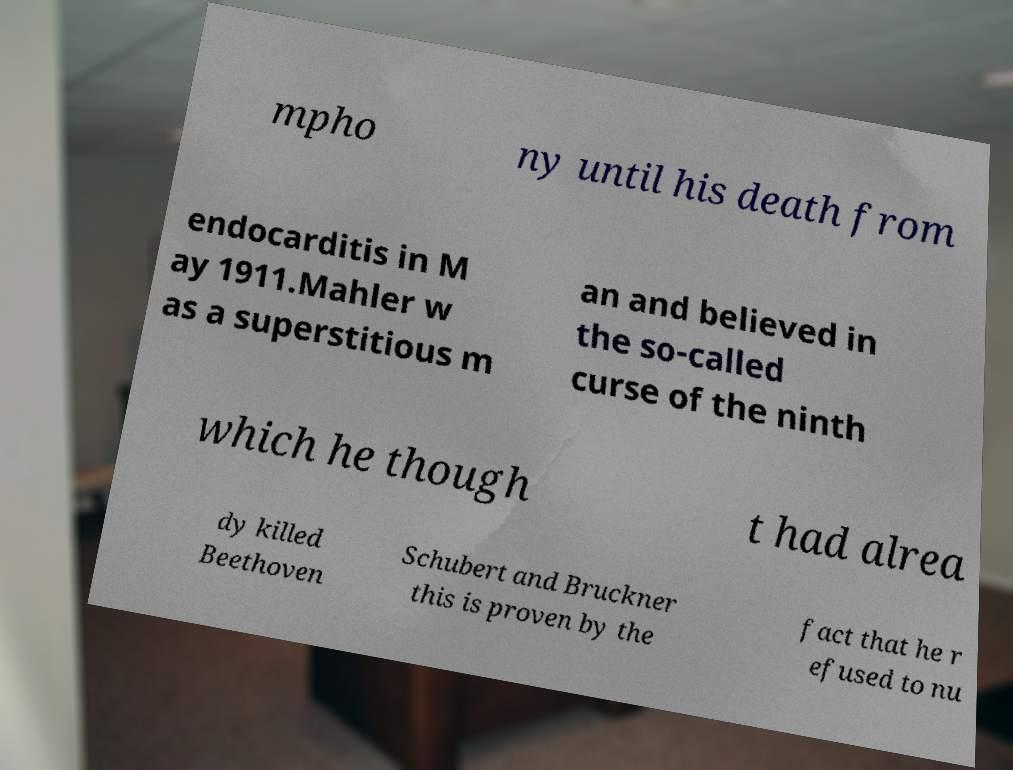For documentation purposes, I need the text within this image transcribed. Could you provide that? mpho ny until his death from endocarditis in M ay 1911.Mahler w as a superstitious m an and believed in the so-called curse of the ninth which he though t had alrea dy killed Beethoven Schubert and Bruckner this is proven by the fact that he r efused to nu 